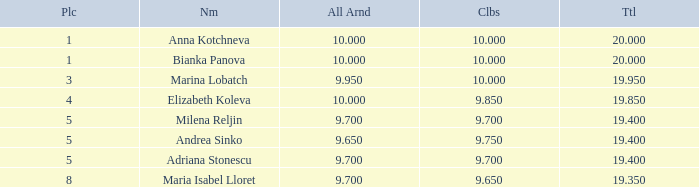What are the lowest clubs that have a place greater than 5, with an all around greater than 9.7? None. 